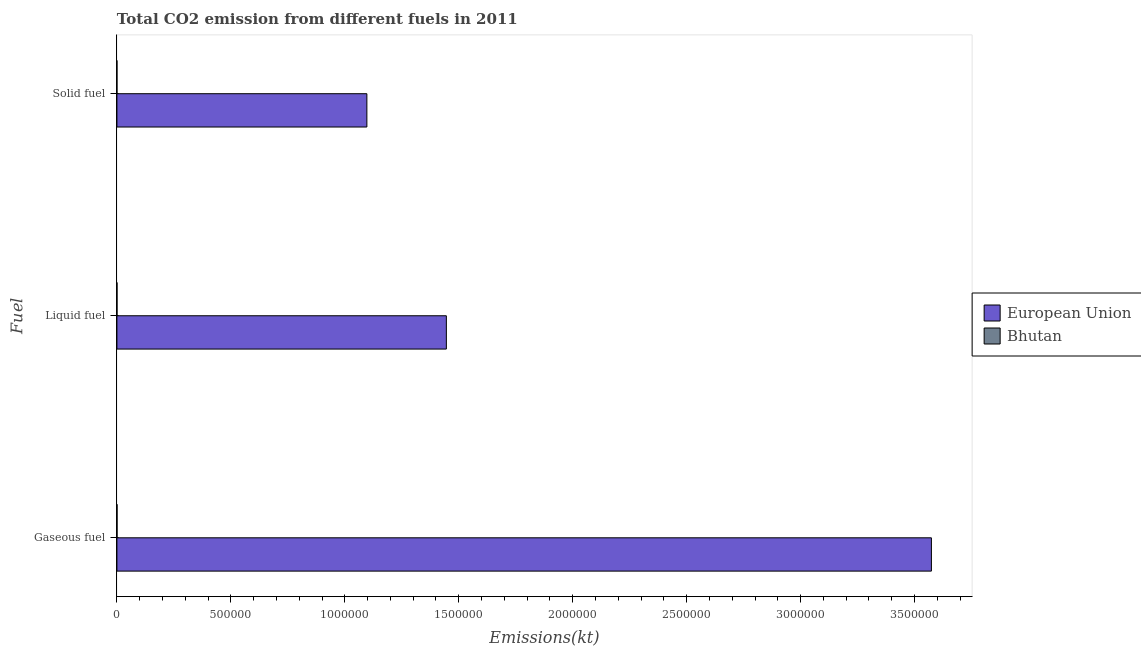How many different coloured bars are there?
Make the answer very short. 2. How many groups of bars are there?
Provide a short and direct response. 3. Are the number of bars on each tick of the Y-axis equal?
Keep it short and to the point. Yes. What is the label of the 2nd group of bars from the top?
Make the answer very short. Liquid fuel. What is the amount of co2 emissions from gaseous fuel in Bhutan?
Make the answer very short. 561.05. Across all countries, what is the maximum amount of co2 emissions from gaseous fuel?
Your answer should be very brief. 3.57e+06. Across all countries, what is the minimum amount of co2 emissions from liquid fuel?
Make the answer very short. 366.7. In which country was the amount of co2 emissions from liquid fuel maximum?
Keep it short and to the point. European Union. In which country was the amount of co2 emissions from solid fuel minimum?
Ensure brevity in your answer.  Bhutan. What is the total amount of co2 emissions from solid fuel in the graph?
Keep it short and to the point. 1.10e+06. What is the difference between the amount of co2 emissions from gaseous fuel in Bhutan and that in European Union?
Ensure brevity in your answer.  -3.57e+06. What is the difference between the amount of co2 emissions from gaseous fuel in European Union and the amount of co2 emissions from liquid fuel in Bhutan?
Your response must be concise. 3.57e+06. What is the average amount of co2 emissions from liquid fuel per country?
Offer a terse response. 7.23e+05. What is the difference between the amount of co2 emissions from solid fuel and amount of co2 emissions from liquid fuel in European Union?
Your answer should be compact. -3.49e+05. In how many countries, is the amount of co2 emissions from liquid fuel greater than 2300000 kt?
Keep it short and to the point. 0. What is the ratio of the amount of co2 emissions from liquid fuel in Bhutan to that in European Union?
Keep it short and to the point. 0. What is the difference between the highest and the second highest amount of co2 emissions from solid fuel?
Provide a short and direct response. 1.10e+06. What is the difference between the highest and the lowest amount of co2 emissions from solid fuel?
Your response must be concise. 1.10e+06. Is the sum of the amount of co2 emissions from solid fuel in Bhutan and European Union greater than the maximum amount of co2 emissions from liquid fuel across all countries?
Give a very brief answer. No. What does the 2nd bar from the top in Liquid fuel represents?
Ensure brevity in your answer.  European Union. What does the 1st bar from the bottom in Gaseous fuel represents?
Provide a succinct answer. European Union. Is it the case that in every country, the sum of the amount of co2 emissions from gaseous fuel and amount of co2 emissions from liquid fuel is greater than the amount of co2 emissions from solid fuel?
Make the answer very short. Yes. How many bars are there?
Ensure brevity in your answer.  6. What is the difference between two consecutive major ticks on the X-axis?
Provide a succinct answer. 5.00e+05. Are the values on the major ticks of X-axis written in scientific E-notation?
Provide a short and direct response. No. Does the graph contain grids?
Your answer should be compact. No. Where does the legend appear in the graph?
Ensure brevity in your answer.  Center right. How many legend labels are there?
Give a very brief answer. 2. What is the title of the graph?
Provide a short and direct response. Total CO2 emission from different fuels in 2011. Does "Arab World" appear as one of the legend labels in the graph?
Your answer should be compact. No. What is the label or title of the X-axis?
Offer a terse response. Emissions(kt). What is the label or title of the Y-axis?
Your answer should be very brief. Fuel. What is the Emissions(kt) of European Union in Gaseous fuel?
Make the answer very short. 3.57e+06. What is the Emissions(kt) of Bhutan in Gaseous fuel?
Provide a short and direct response. 561.05. What is the Emissions(kt) of European Union in Liquid fuel?
Keep it short and to the point. 1.45e+06. What is the Emissions(kt) in Bhutan in Liquid fuel?
Your answer should be very brief. 366.7. What is the Emissions(kt) of European Union in Solid fuel?
Make the answer very short. 1.10e+06. What is the Emissions(kt) in Bhutan in Solid fuel?
Keep it short and to the point. 95.34. Across all Fuel, what is the maximum Emissions(kt) of European Union?
Give a very brief answer. 3.57e+06. Across all Fuel, what is the maximum Emissions(kt) of Bhutan?
Your answer should be compact. 561.05. Across all Fuel, what is the minimum Emissions(kt) in European Union?
Your response must be concise. 1.10e+06. Across all Fuel, what is the minimum Emissions(kt) of Bhutan?
Make the answer very short. 95.34. What is the total Emissions(kt) of European Union in the graph?
Your answer should be very brief. 6.12e+06. What is the total Emissions(kt) of Bhutan in the graph?
Keep it short and to the point. 1023.09. What is the difference between the Emissions(kt) in European Union in Gaseous fuel and that in Liquid fuel?
Give a very brief answer. 2.13e+06. What is the difference between the Emissions(kt) in Bhutan in Gaseous fuel and that in Liquid fuel?
Make the answer very short. 194.35. What is the difference between the Emissions(kt) in European Union in Gaseous fuel and that in Solid fuel?
Give a very brief answer. 2.48e+06. What is the difference between the Emissions(kt) of Bhutan in Gaseous fuel and that in Solid fuel?
Ensure brevity in your answer.  465.71. What is the difference between the Emissions(kt) of European Union in Liquid fuel and that in Solid fuel?
Provide a short and direct response. 3.49e+05. What is the difference between the Emissions(kt) in Bhutan in Liquid fuel and that in Solid fuel?
Offer a terse response. 271.36. What is the difference between the Emissions(kt) in European Union in Gaseous fuel and the Emissions(kt) in Bhutan in Liquid fuel?
Your answer should be very brief. 3.57e+06. What is the difference between the Emissions(kt) of European Union in Gaseous fuel and the Emissions(kt) of Bhutan in Solid fuel?
Offer a terse response. 3.57e+06. What is the difference between the Emissions(kt) in European Union in Liquid fuel and the Emissions(kt) in Bhutan in Solid fuel?
Give a very brief answer. 1.45e+06. What is the average Emissions(kt) in European Union per Fuel?
Ensure brevity in your answer.  2.04e+06. What is the average Emissions(kt) in Bhutan per Fuel?
Your answer should be compact. 341.03. What is the difference between the Emissions(kt) in European Union and Emissions(kt) in Bhutan in Gaseous fuel?
Give a very brief answer. 3.57e+06. What is the difference between the Emissions(kt) of European Union and Emissions(kt) of Bhutan in Liquid fuel?
Offer a terse response. 1.45e+06. What is the difference between the Emissions(kt) in European Union and Emissions(kt) in Bhutan in Solid fuel?
Ensure brevity in your answer.  1.10e+06. What is the ratio of the Emissions(kt) in European Union in Gaseous fuel to that in Liquid fuel?
Provide a succinct answer. 2.47. What is the ratio of the Emissions(kt) of Bhutan in Gaseous fuel to that in Liquid fuel?
Give a very brief answer. 1.53. What is the ratio of the Emissions(kt) in European Union in Gaseous fuel to that in Solid fuel?
Offer a terse response. 3.26. What is the ratio of the Emissions(kt) in Bhutan in Gaseous fuel to that in Solid fuel?
Your answer should be compact. 5.88. What is the ratio of the Emissions(kt) of European Union in Liquid fuel to that in Solid fuel?
Provide a succinct answer. 1.32. What is the ratio of the Emissions(kt) in Bhutan in Liquid fuel to that in Solid fuel?
Your answer should be very brief. 3.85. What is the difference between the highest and the second highest Emissions(kt) in European Union?
Offer a terse response. 2.13e+06. What is the difference between the highest and the second highest Emissions(kt) of Bhutan?
Your response must be concise. 194.35. What is the difference between the highest and the lowest Emissions(kt) in European Union?
Provide a succinct answer. 2.48e+06. What is the difference between the highest and the lowest Emissions(kt) in Bhutan?
Your answer should be compact. 465.71. 